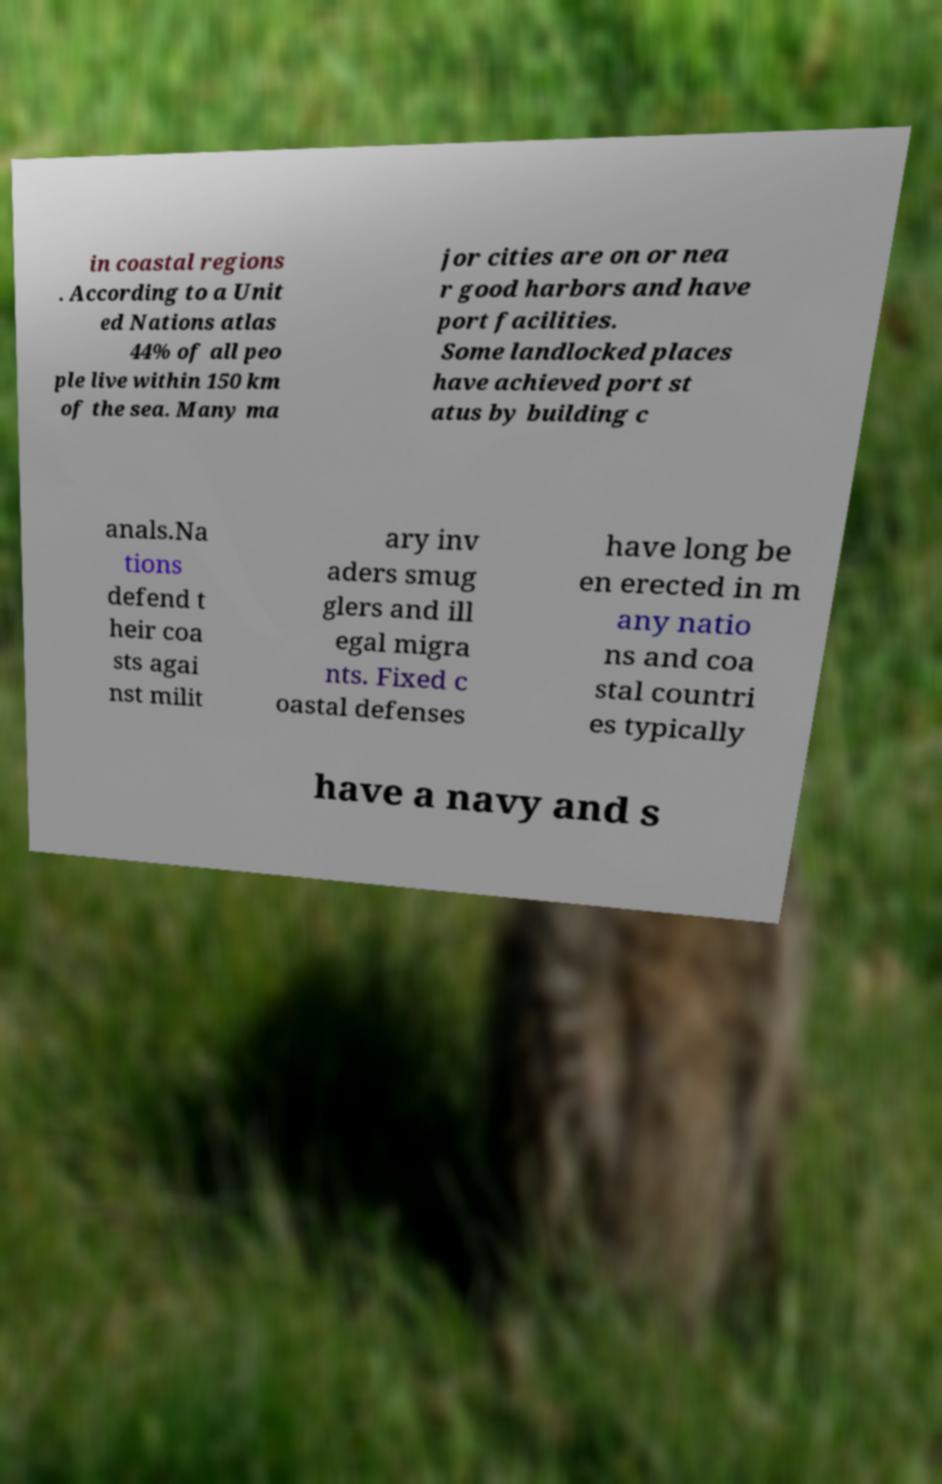I need the written content from this picture converted into text. Can you do that? in coastal regions . According to a Unit ed Nations atlas 44% of all peo ple live within 150 km of the sea. Many ma jor cities are on or nea r good harbors and have port facilities. Some landlocked places have achieved port st atus by building c anals.Na tions defend t heir coa sts agai nst milit ary inv aders smug glers and ill egal migra nts. Fixed c oastal defenses have long be en erected in m any natio ns and coa stal countri es typically have a navy and s 